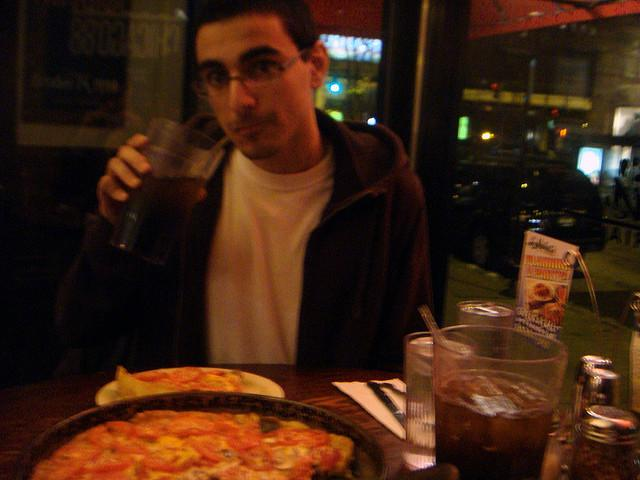What color is the soft drink drank by the man at the pizza store? Please explain your reasoning. brown. The fluid in both glasses visible in this image is brown, though it appears nearly black in low light. 